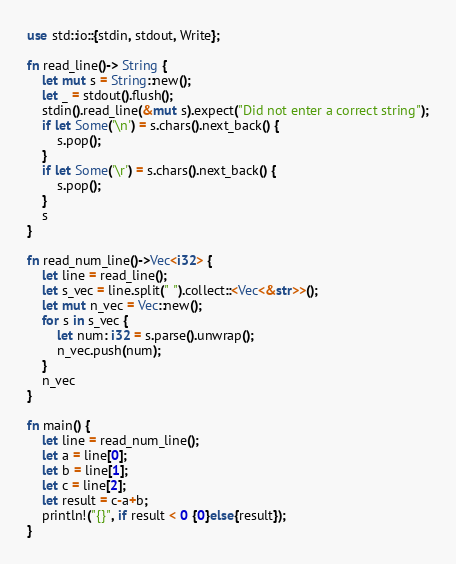Convert code to text. <code><loc_0><loc_0><loc_500><loc_500><_Rust_>use std::io::{stdin, stdout, Write};

fn read_line()-> String {
    let mut s = String::new();
    let _ = stdout().flush();
    stdin().read_line(&mut s).expect("Did not enter a correct string");
    if let Some('\n') = s.chars().next_back() {
        s.pop();
    }
    if let Some('\r') = s.chars().next_back() {
        s.pop();
    }
    s
}

fn read_num_line()->Vec<i32> {
    let line = read_line();
    let s_vec = line.split(" ").collect::<Vec<&str>>();
    let mut n_vec = Vec::new();
    for s in s_vec {
        let num: i32 = s.parse().unwrap();
        n_vec.push(num);
    }
    n_vec
}

fn main() {
    let line = read_num_line();
    let a = line[0];
    let b = line[1];
    let c = line[2];
    let result = c-a+b;
    println!("{}", if result < 0 {0}else{result});
}
</code> 